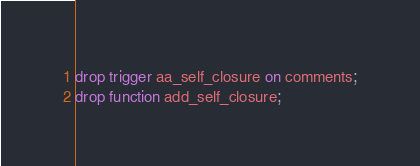Convert code to text. <code><loc_0><loc_0><loc_500><loc_500><_SQL_>drop trigger aa_self_closure on comments;
drop function add_self_closure;
</code> 